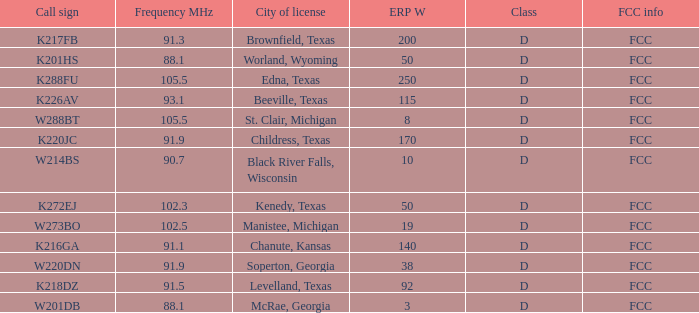What is City of License, when Frequency MHz is less than 102.5? McRae, Georgia, Soperton, Georgia, Chanute, Kansas, Beeville, Texas, Brownfield, Texas, Childress, Texas, Kenedy, Texas, Levelland, Texas, Black River Falls, Wisconsin, Worland, Wyoming. 